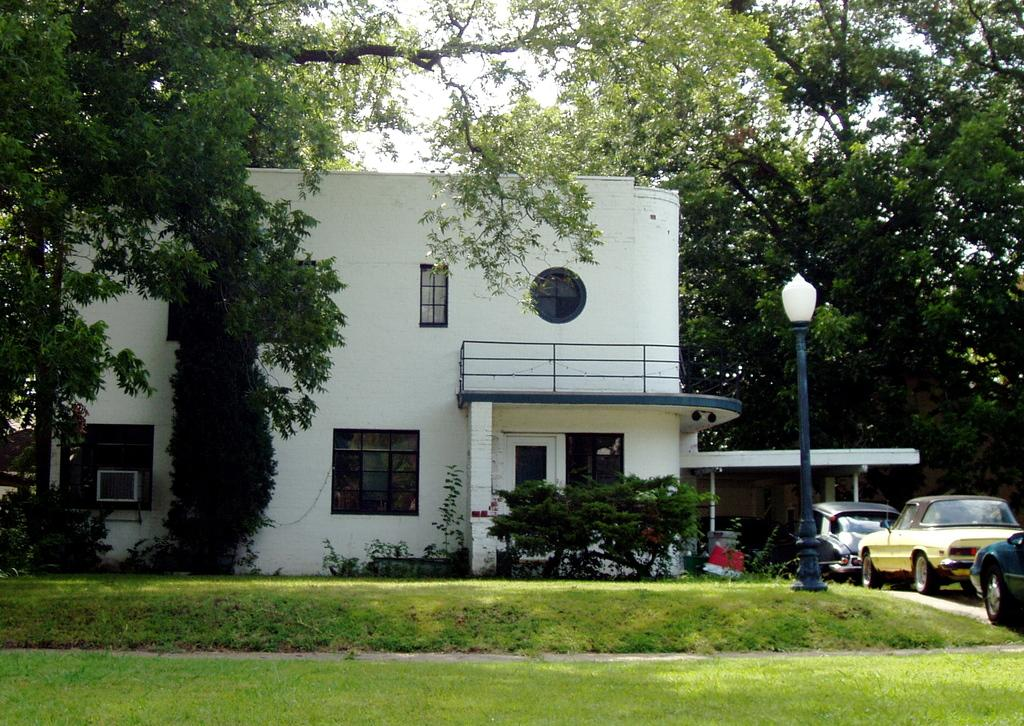What type of vegetation can be seen in the image? There are trees in the image. What type of structure is present in the image? There is a building in the image. What feature of the building is visible in the image? There are windows in the image. What type of street furniture is present in the image? There is a light pole in the image. What type of transportation is visible in the image? There are vehicles in the image. What type of ground cover is present in the image? There is green grass in the image. What is the color of the sky in the image? The sky appears to be white in color. What type of rod can be seen in the image? There is no rod present in the image. Can you describe the stranger in the image? There is no stranger present in the image. 